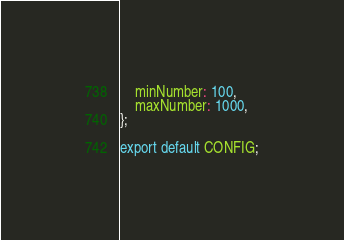Convert code to text. <code><loc_0><loc_0><loc_500><loc_500><_TypeScript_>    minNumber: 100,
    maxNumber: 1000,
};

export default CONFIG;
</code> 